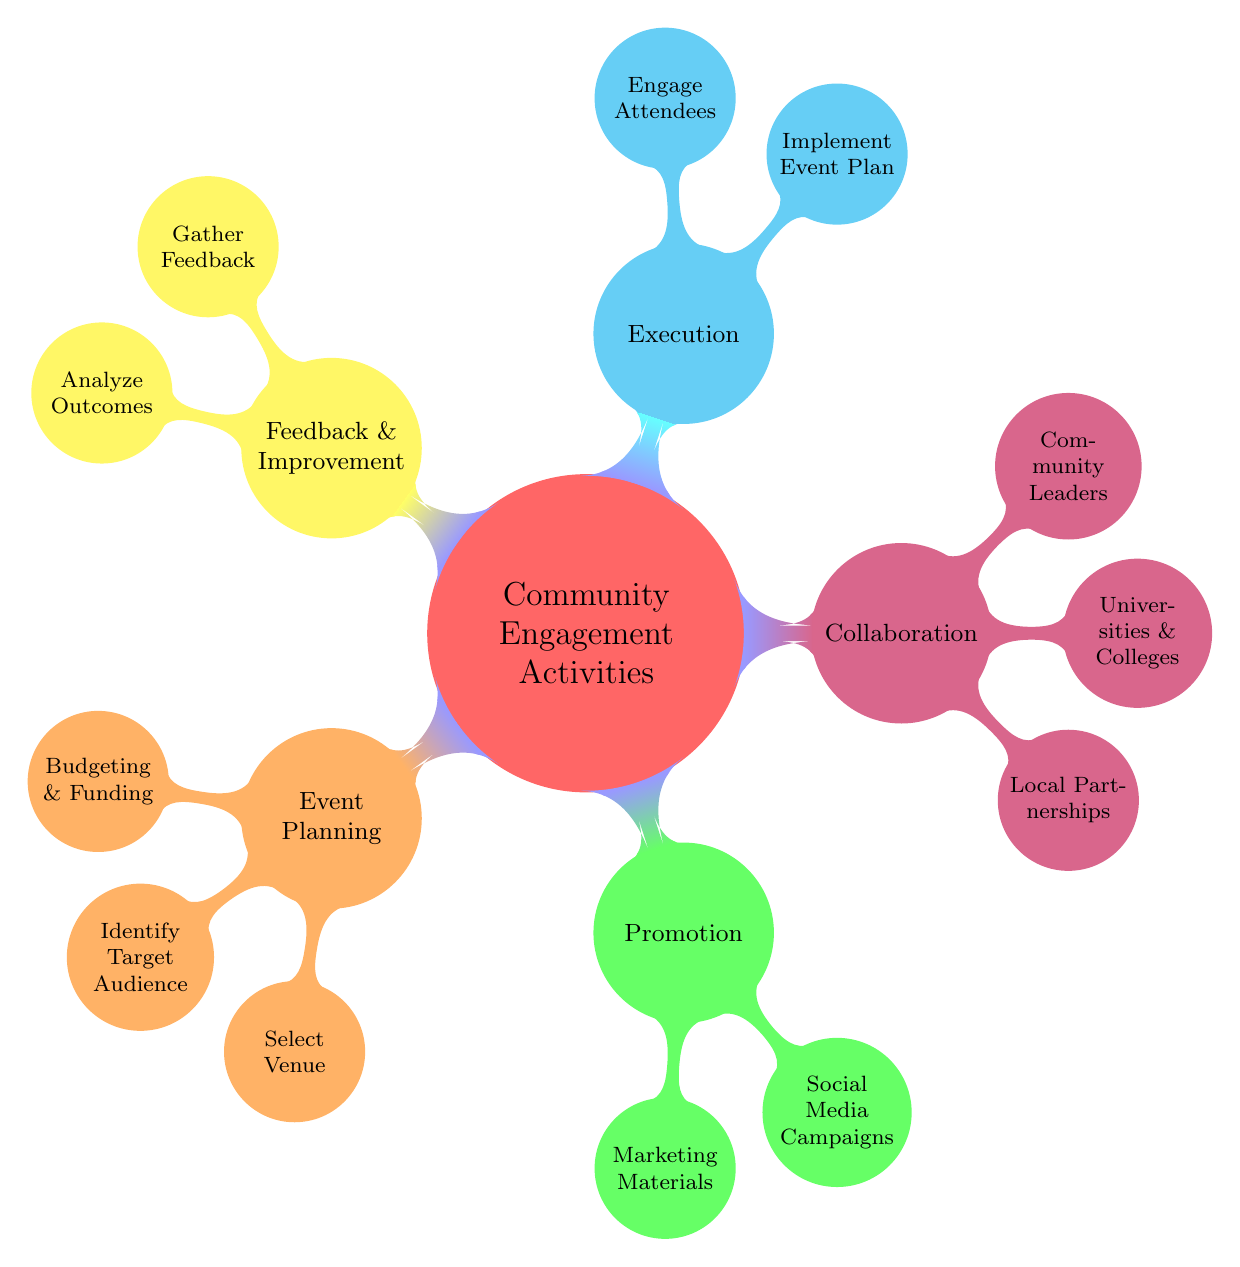What is the main topic of the diagram? The main topic of the diagram is identified at the center node, which is labeled as "Community Engagement Activities." This serves as the primary focus of the entire structure.
Answer: Community Engagement Activities How many main categories are there in the diagram? By examining the top-level nodes directly attached to the main topic, we can count five distinct categories: Event Planning, Promotion, Collaboration, Execution, and Feedback & Improvement.
Answer: 5 What does the "Execution" category include? Under the "Execution" category, there are two sub-nodes: "Implement Event Plan" and "Engage Attendees." These represent the specific actions involved in executing community engagement activities.
Answer: Implement Event Plan, Engage Attendees Which category includes "Local Partnerships"? "Local Partnerships" is found within the "Collaboration" category. This indicates that establishing local partnerships is a key aspect of collaborating in community engagement activities.
Answer: Collaboration What is the relationship between "Budgeting & Funding" and "Event Planning"? "Budgeting & Funding" is a sub-node that directly descends from the "Event Planning" category, indicating that it is a fundamental aspect of planning community events.
Answer: It is a sub-node of Event Planning How can feedback be gathered according to the diagram? The diagram specifies "Gather Feedback" as a sub-node under the "Feedback & Improvement" category. This indicates that gathering feedback is a planned step in the process.
Answer: Gather Feedback What is one method of promotion mentioned in the diagram? According to the diagram, one method of promotion listed is "Social Media Campaigns," indicating the use of digital platforms to promote community engagement activities.
Answer: Social Media Campaigns How many collaborators are mentioned in the "Collaboration" category? There are three collaborators mentioned in the "Collaboration" category: "Local Partnerships," "Universities & Colleges," and "Community Leaders." Thus, we count a total of three collaborators.
Answer: 3 What are two actions listed under the "Feedback & Improvement" category? The actions listed under "Feedback & Improvement" are "Gather Feedback" and "Analyze Outcomes." These steps illustrate the importance of both collecting feedback and evaluating it to improve future activities.
Answer: Gather Feedback, Analyze Outcomes 